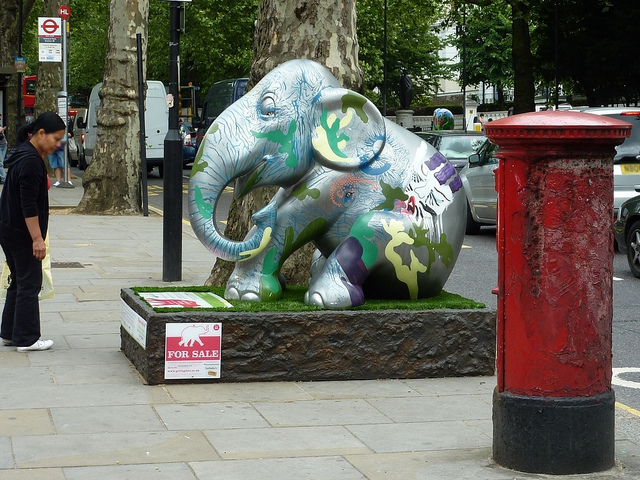What does the elephant's pose suggest to you? The sculpture's pose, with the trunk uplifted and seeming playful, often signifies good luck and positivity in some cultures. It may also aim to evoke a sense of joy and whimsy in the viewers, reflecting the elephant's gentle nature in stark contrast to its grand size. 